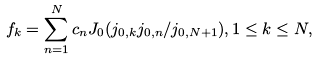Convert formula to latex. <formula><loc_0><loc_0><loc_500><loc_500>f _ { k } = \sum _ { n = 1 } ^ { N } c _ { n } J _ { 0 } ( j _ { 0 , k } j _ { 0 , n } / j _ { 0 , N + 1 } ) , 1 \leq k \leq N ,</formula> 